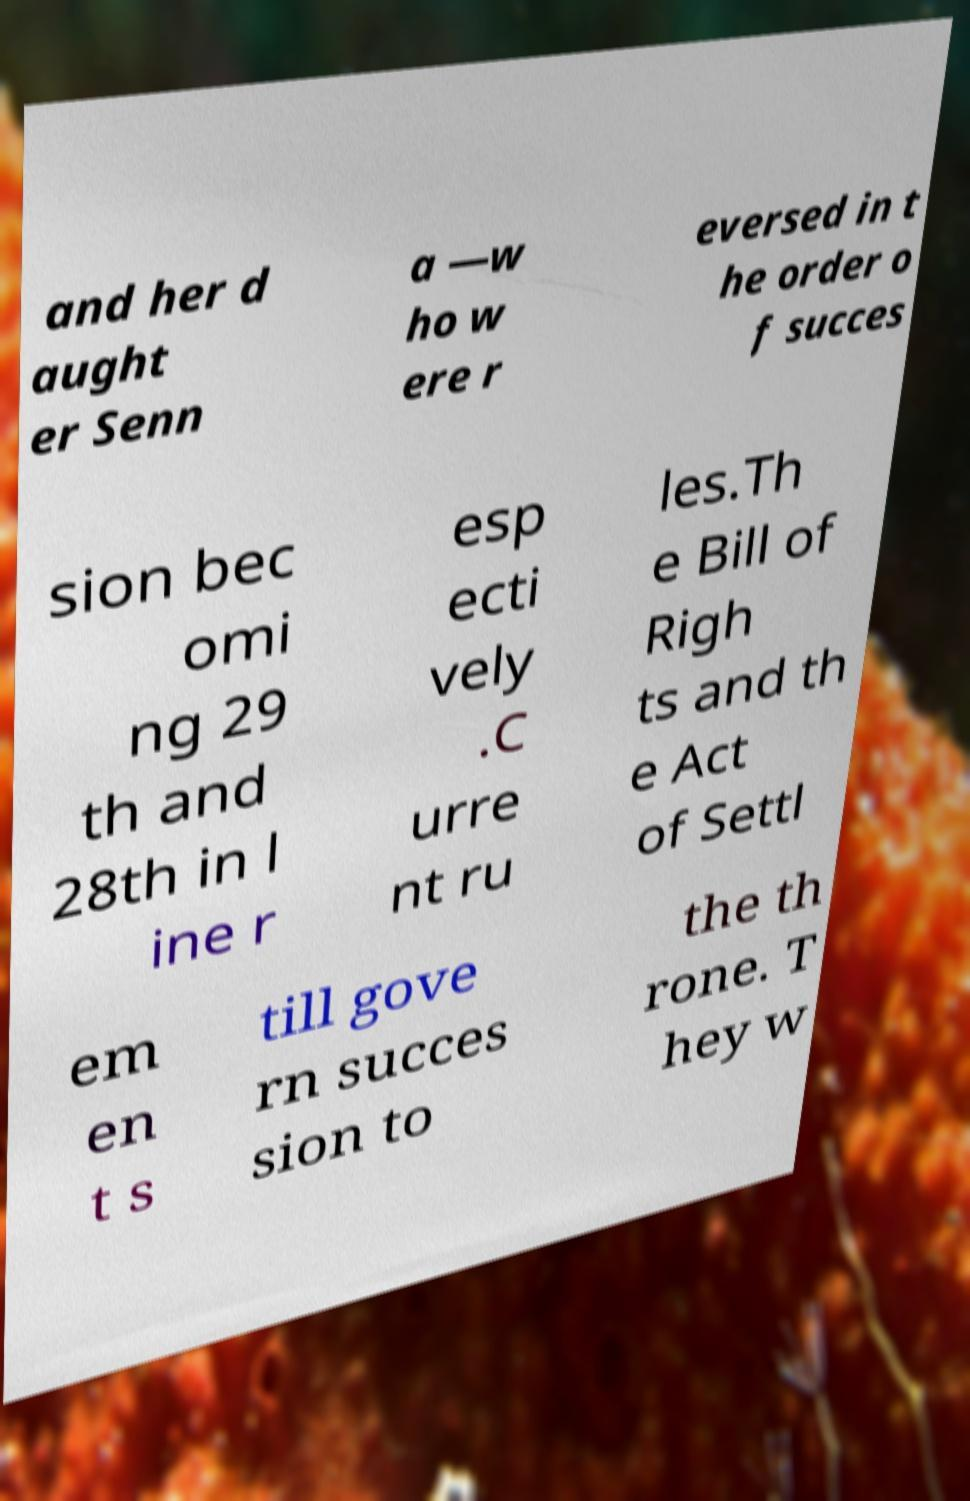Could you extract and type out the text from this image? and her d aught er Senn a —w ho w ere r eversed in t he order o f succes sion bec omi ng 29 th and 28th in l ine r esp ecti vely .C urre nt ru les.Th e Bill of Righ ts and th e Act of Settl em en t s till gove rn succes sion to the th rone. T hey w 